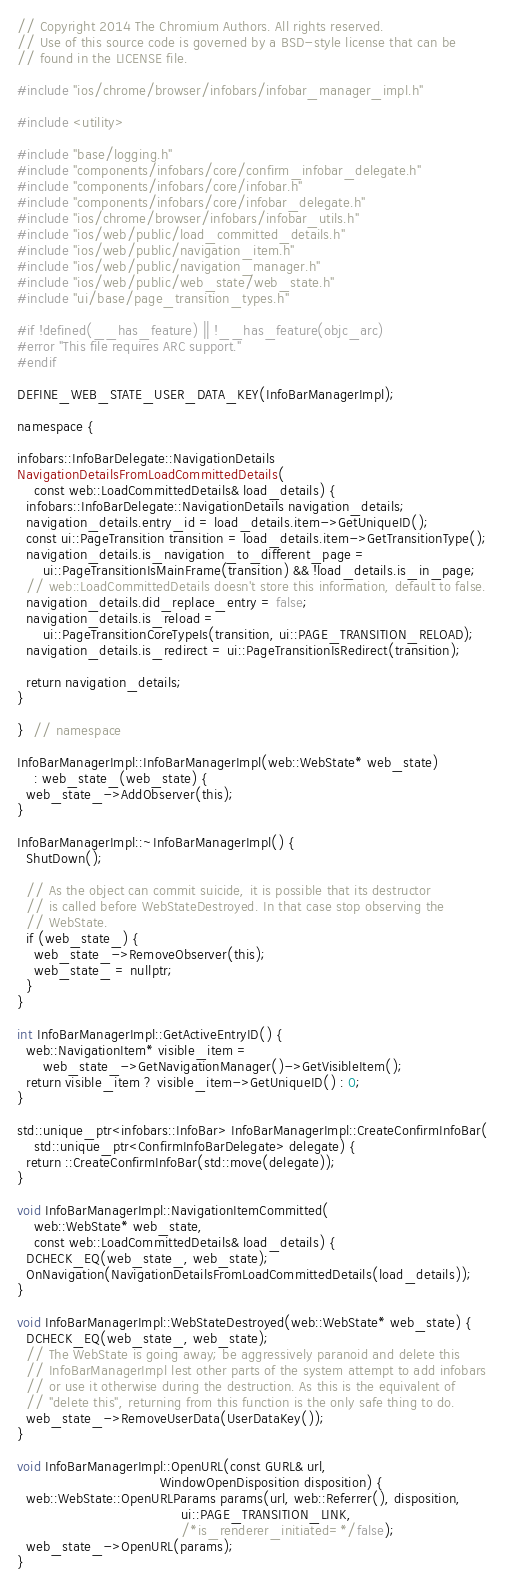Convert code to text. <code><loc_0><loc_0><loc_500><loc_500><_ObjectiveC_>// Copyright 2014 The Chromium Authors. All rights reserved.
// Use of this source code is governed by a BSD-style license that can be
// found in the LICENSE file.

#include "ios/chrome/browser/infobars/infobar_manager_impl.h"

#include <utility>

#include "base/logging.h"
#include "components/infobars/core/confirm_infobar_delegate.h"
#include "components/infobars/core/infobar.h"
#include "components/infobars/core/infobar_delegate.h"
#include "ios/chrome/browser/infobars/infobar_utils.h"
#include "ios/web/public/load_committed_details.h"
#include "ios/web/public/navigation_item.h"
#include "ios/web/public/navigation_manager.h"
#include "ios/web/public/web_state/web_state.h"
#include "ui/base/page_transition_types.h"

#if !defined(__has_feature) || !__has_feature(objc_arc)
#error "This file requires ARC support."
#endif

DEFINE_WEB_STATE_USER_DATA_KEY(InfoBarManagerImpl);

namespace {

infobars::InfoBarDelegate::NavigationDetails
NavigationDetailsFromLoadCommittedDetails(
    const web::LoadCommittedDetails& load_details) {
  infobars::InfoBarDelegate::NavigationDetails navigation_details;
  navigation_details.entry_id = load_details.item->GetUniqueID();
  const ui::PageTransition transition = load_details.item->GetTransitionType();
  navigation_details.is_navigation_to_different_page =
      ui::PageTransitionIsMainFrame(transition) && !load_details.is_in_page;
  // web::LoadCommittedDetails doesn't store this information, default to false.
  navigation_details.did_replace_entry = false;
  navigation_details.is_reload =
      ui::PageTransitionCoreTypeIs(transition, ui::PAGE_TRANSITION_RELOAD);
  navigation_details.is_redirect = ui::PageTransitionIsRedirect(transition);

  return navigation_details;
}

}  // namespace

InfoBarManagerImpl::InfoBarManagerImpl(web::WebState* web_state)
    : web_state_(web_state) {
  web_state_->AddObserver(this);
}

InfoBarManagerImpl::~InfoBarManagerImpl() {
  ShutDown();

  // As the object can commit suicide, it is possible that its destructor
  // is called before WebStateDestroyed. In that case stop observing the
  // WebState.
  if (web_state_) {
    web_state_->RemoveObserver(this);
    web_state_ = nullptr;
  }
}

int InfoBarManagerImpl::GetActiveEntryID() {
  web::NavigationItem* visible_item =
      web_state_->GetNavigationManager()->GetVisibleItem();
  return visible_item ? visible_item->GetUniqueID() : 0;
}

std::unique_ptr<infobars::InfoBar> InfoBarManagerImpl::CreateConfirmInfoBar(
    std::unique_ptr<ConfirmInfoBarDelegate> delegate) {
  return ::CreateConfirmInfoBar(std::move(delegate));
}

void InfoBarManagerImpl::NavigationItemCommitted(
    web::WebState* web_state,
    const web::LoadCommittedDetails& load_details) {
  DCHECK_EQ(web_state_, web_state);
  OnNavigation(NavigationDetailsFromLoadCommittedDetails(load_details));
}

void InfoBarManagerImpl::WebStateDestroyed(web::WebState* web_state) {
  DCHECK_EQ(web_state_, web_state);
  // The WebState is going away; be aggressively paranoid and delete this
  // InfoBarManagerImpl lest other parts of the system attempt to add infobars
  // or use it otherwise during the destruction. As this is the equivalent of
  // "delete this", returning from this function is the only safe thing to do.
  web_state_->RemoveUserData(UserDataKey());
}

void InfoBarManagerImpl::OpenURL(const GURL& url,
                                 WindowOpenDisposition disposition) {
  web::WebState::OpenURLParams params(url, web::Referrer(), disposition,
                                      ui::PAGE_TRANSITION_LINK,
                                      /*is_renderer_initiated=*/false);
  web_state_->OpenURL(params);
}
</code> 